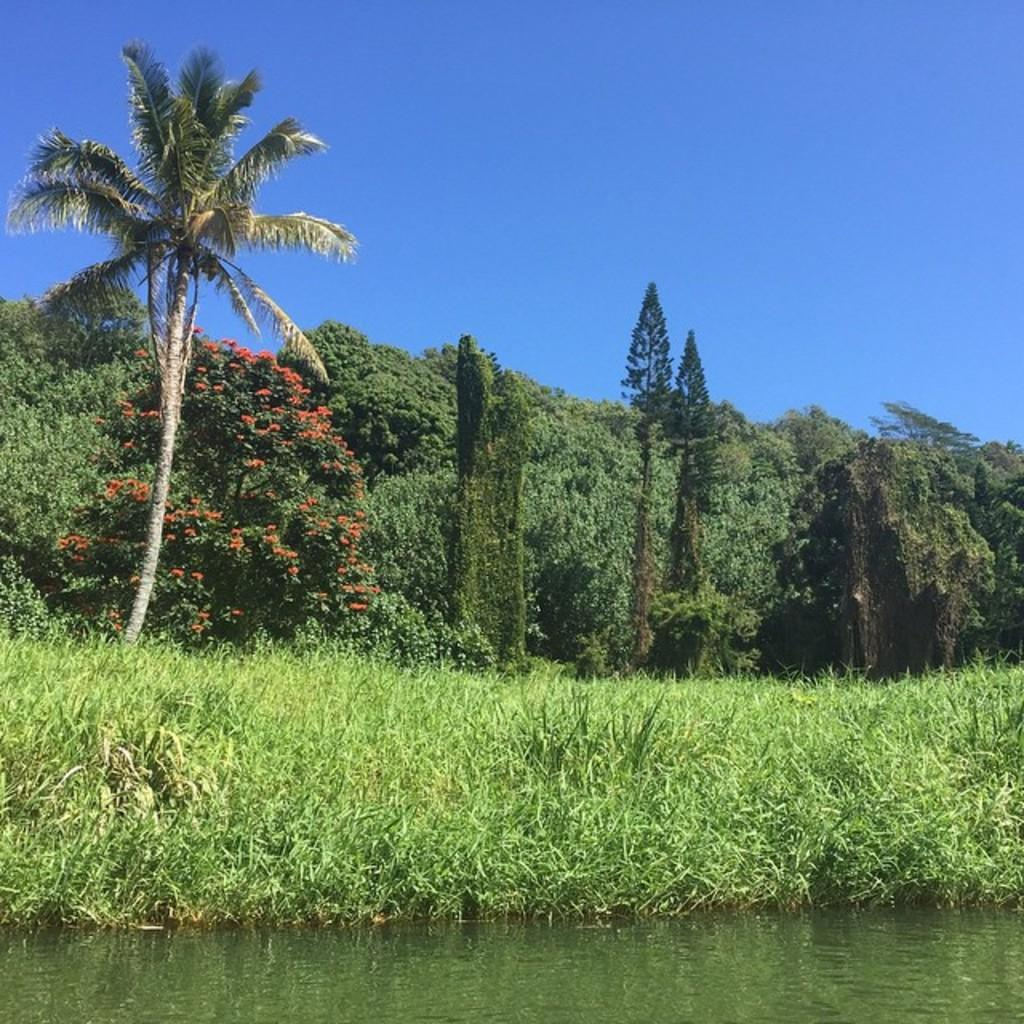What type of vegetation can be seen in the image? There is grass in the image. What else can be seen in the image besides grass? There is water, a plant, a tree, and the sky visible in the image. Can you describe the plant in the image? The plant in the image is not specified, but it is present along with the grass, water, and tree. How many rabbits are sitting on the icicle in the image? There are no rabbits or icicles present in the image. What discovery was made while observing the image? There is no mention of a discovery in the image or the provided facts. 